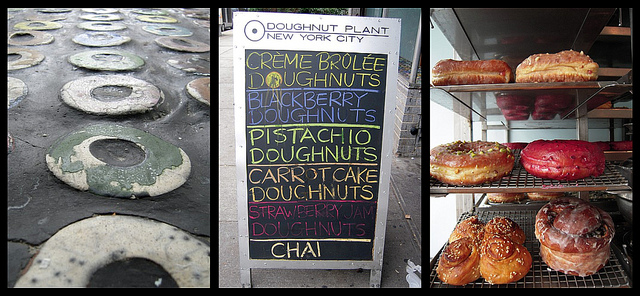Extract all visible text content from this image. DOUGHNUT PLANT NEW YORK BLACKBERRY CHAI DOUGHNUTS JAM STRAWBERRY DOUCHNUTS CAKE CARROT DOUGHNUTS PISTACHIO DOUGHNUTS DOUGHNUTS CREME BROLEE CITY 